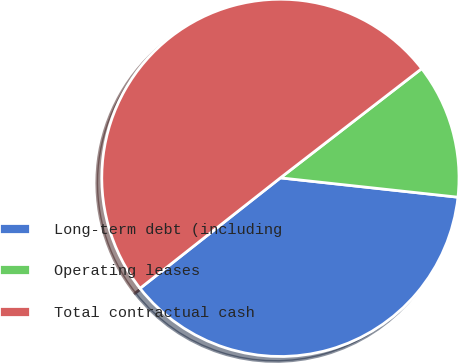Convert chart to OTSL. <chart><loc_0><loc_0><loc_500><loc_500><pie_chart><fcel>Long-term debt (including<fcel>Operating leases<fcel>Total contractual cash<nl><fcel>37.66%<fcel>12.2%<fcel>50.14%<nl></chart> 